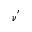Convert formula to latex. <formula><loc_0><loc_0><loc_500><loc_500>\nu ^ { ^ { \prime } }</formula> 